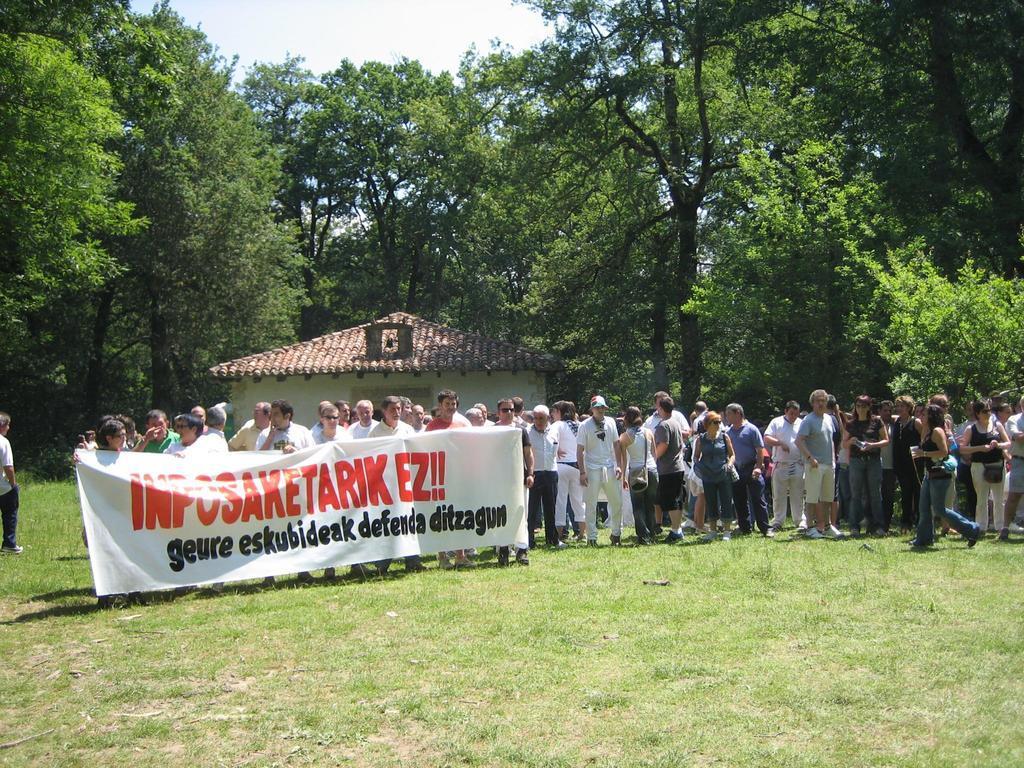In one or two sentences, can you explain what this image depicts? In this picture there are people, among them few people holding banner and we can see grass. In the background of the image we can see house, trees and sky. 